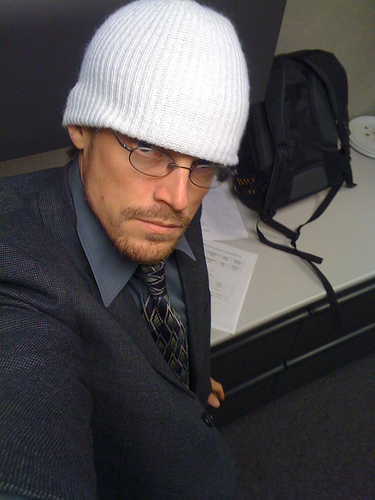<image>What location are the people at? It is unknown where the people are located. It could be an office, school, or indoors. What does his hat say? His hat says nothing. What location are the people at? The people in the image are at an unknown location. They could be at a school, work, office, or indoors. What does his hat say? I don't know what does his hat say. It seems like there is nothing written on his hat. 